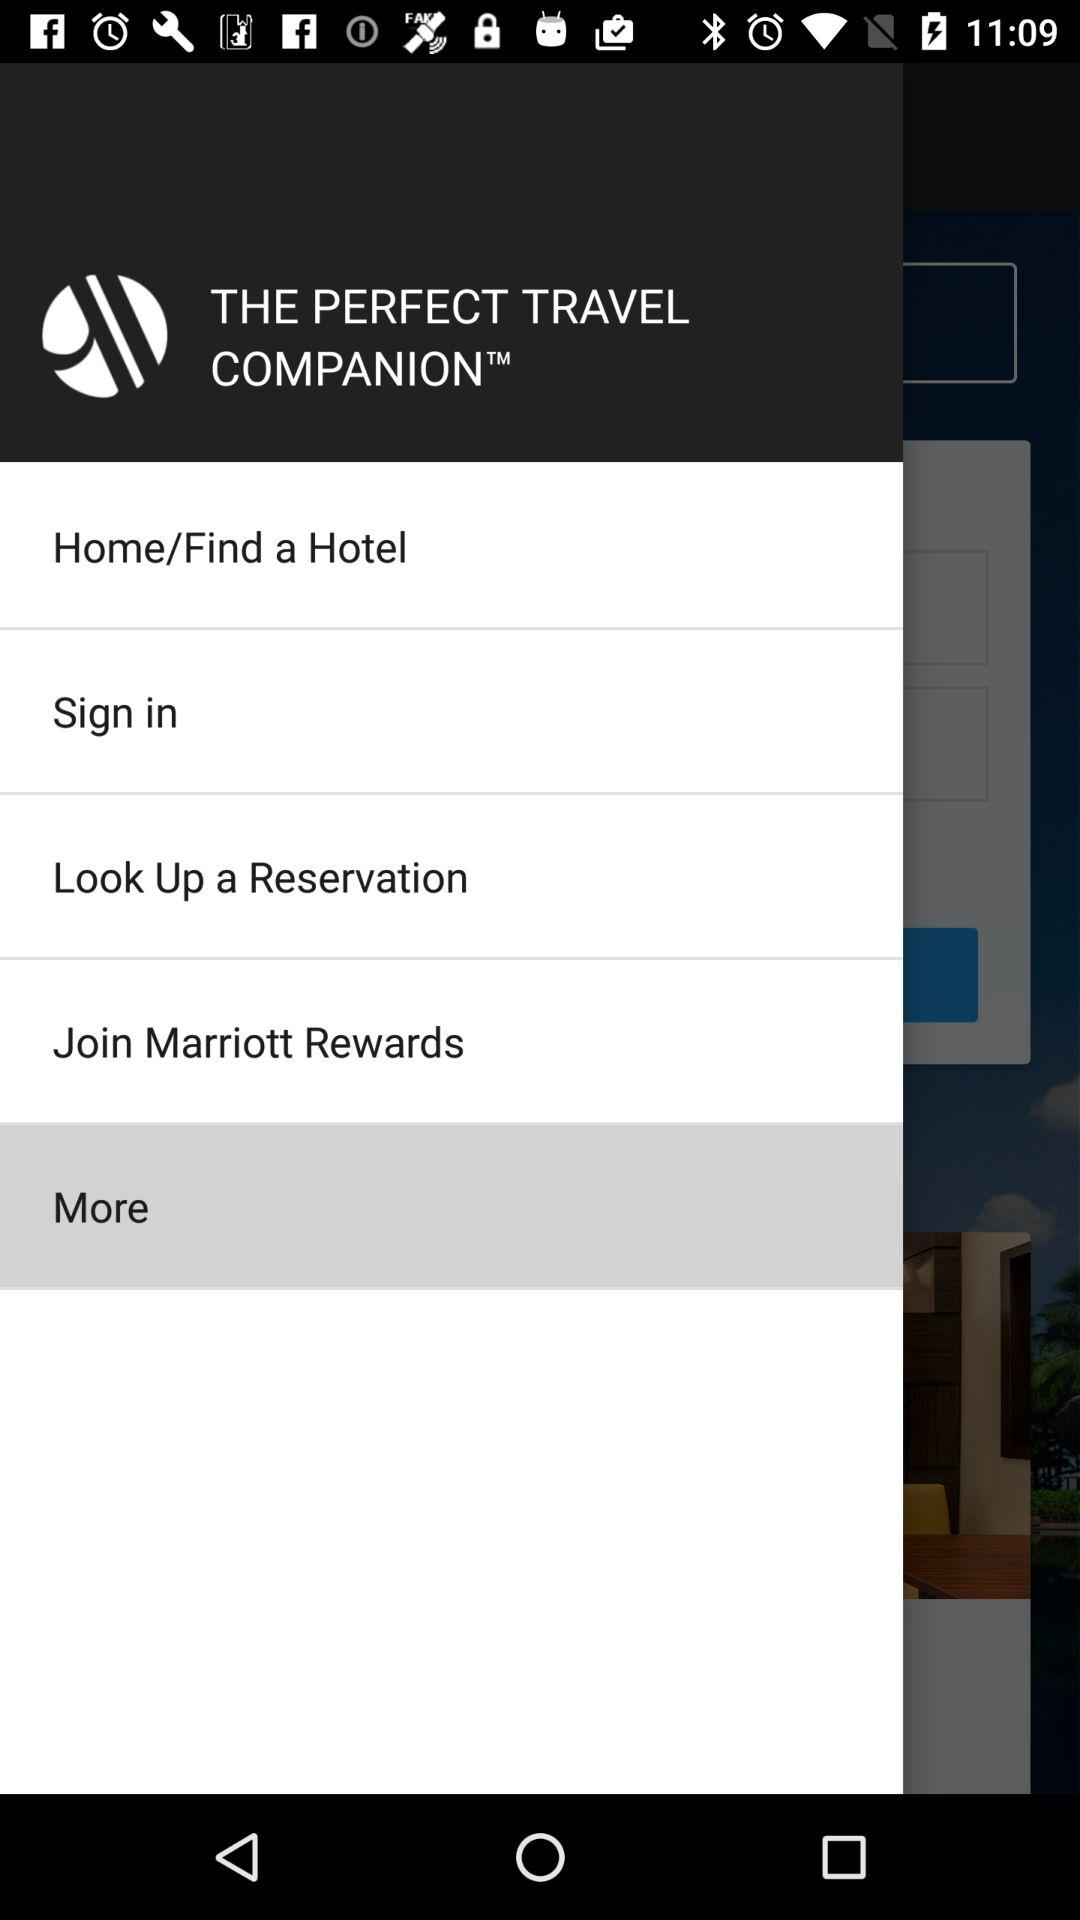What's the highlighted menu item? The highlighted menu item is "More". 